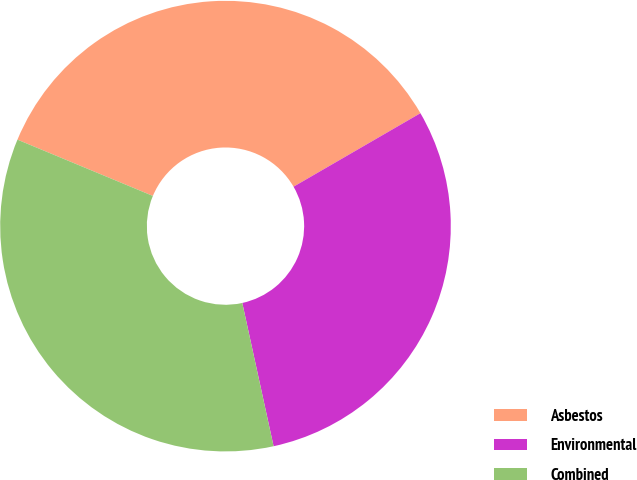<chart> <loc_0><loc_0><loc_500><loc_500><pie_chart><fcel>Asbestos<fcel>Environmental<fcel>Combined<nl><fcel>35.37%<fcel>29.93%<fcel>34.69%<nl></chart> 